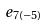<formula> <loc_0><loc_0><loc_500><loc_500>e _ { 7 ( - 5 ) }</formula> 